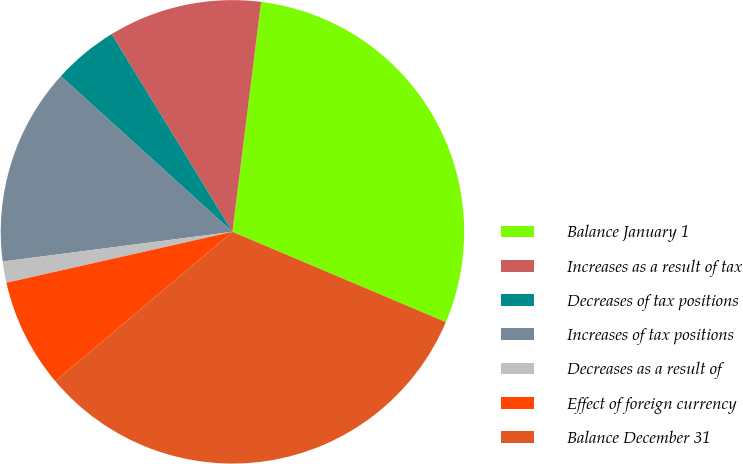<chart> <loc_0><loc_0><loc_500><loc_500><pie_chart><fcel>Balance January 1<fcel>Increases as a result of tax<fcel>Decreases of tax positions<fcel>Increases of tax positions<fcel>Decreases as a result of<fcel>Effect of foreign currency<fcel>Balance December 31<nl><fcel>29.4%<fcel>10.7%<fcel>4.55%<fcel>13.77%<fcel>1.48%<fcel>7.62%<fcel>32.48%<nl></chart> 